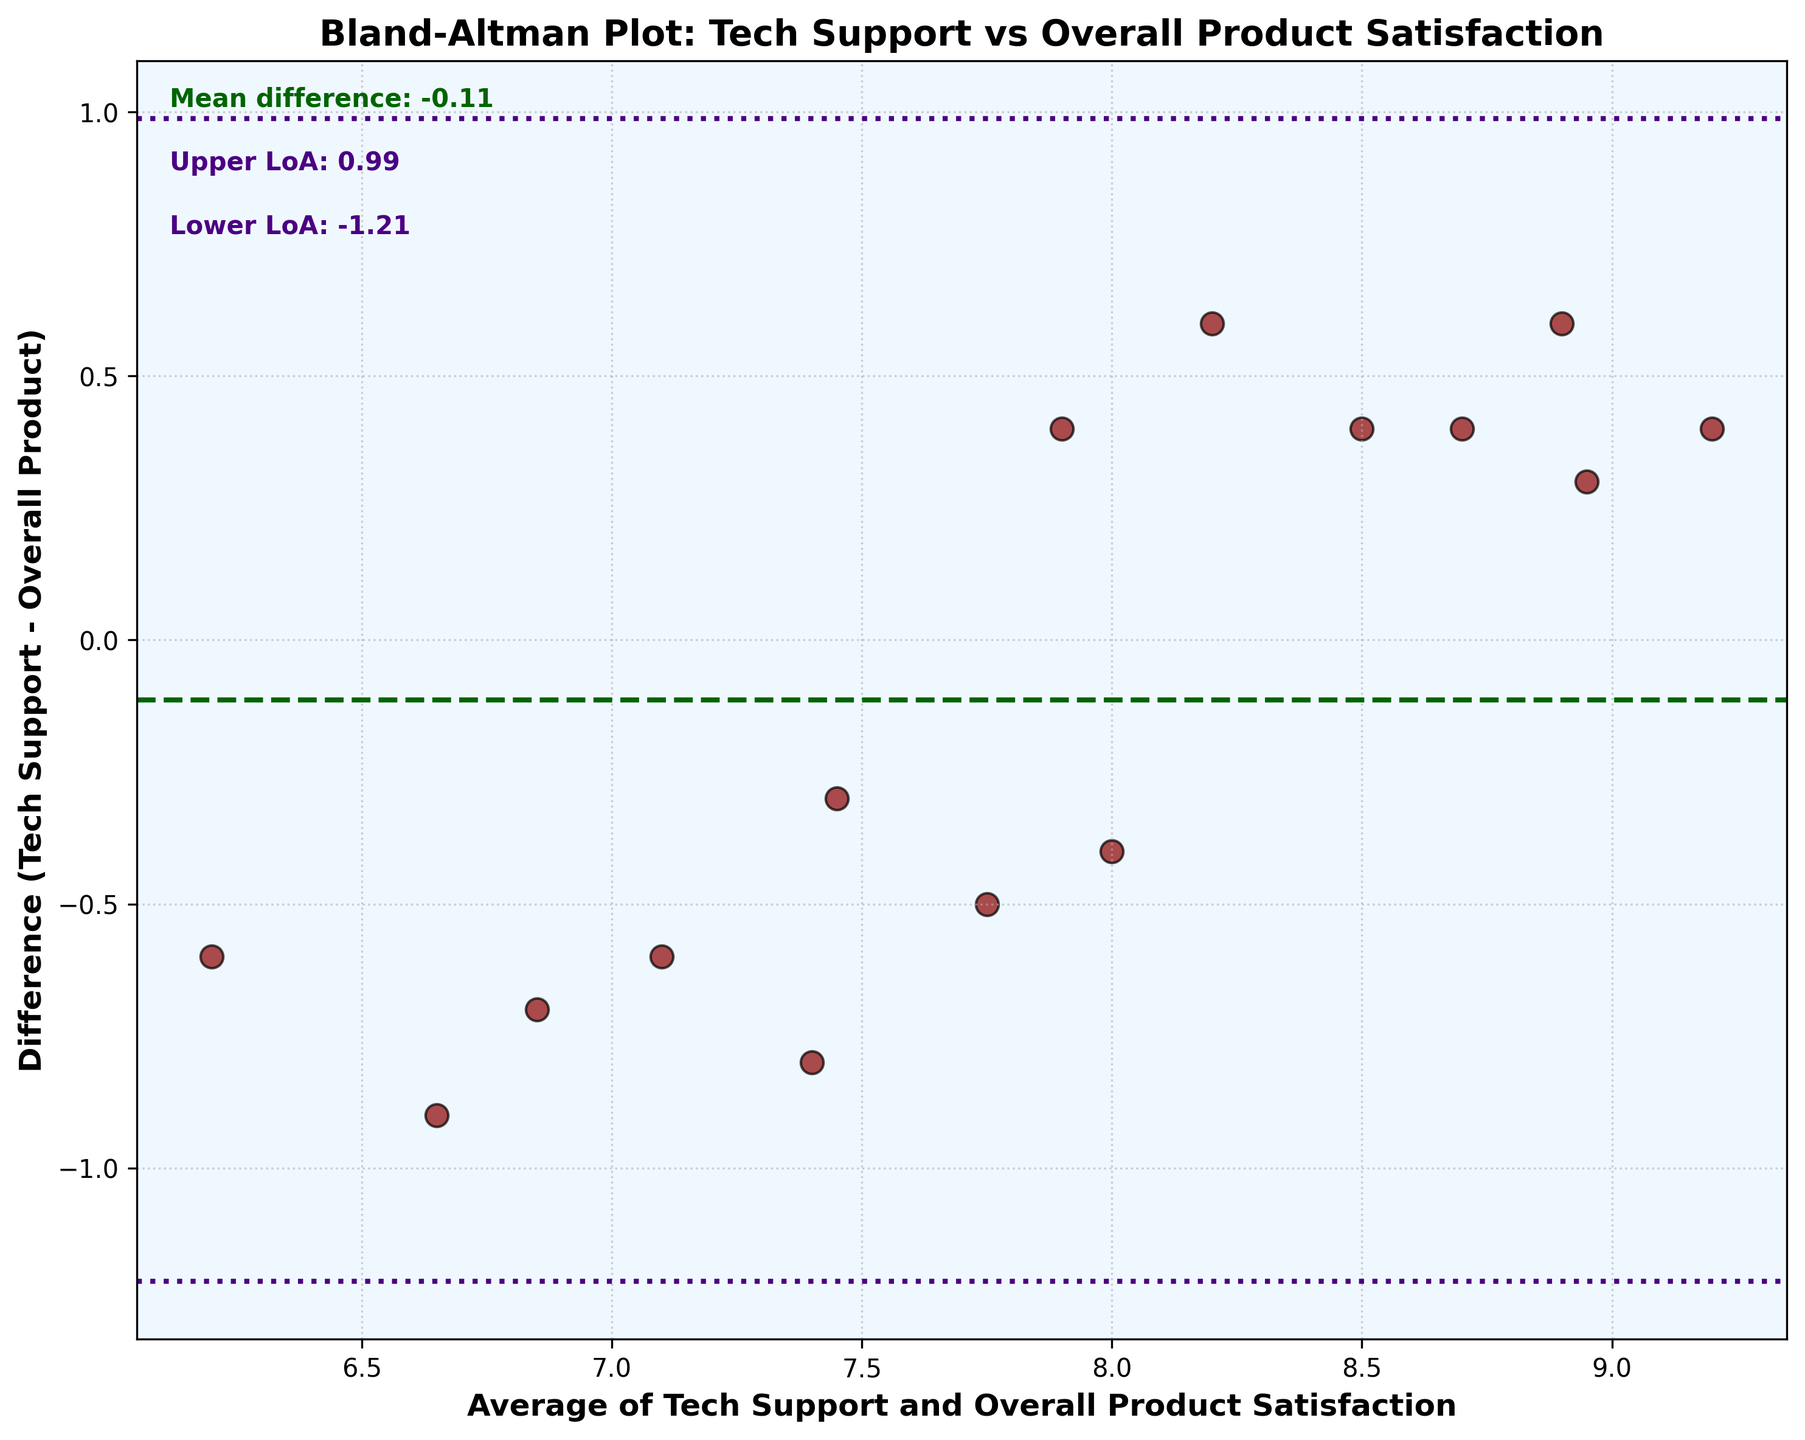What's the main title of the plot? The title is located at the top of the figure and provides an overview of what the plot represents. In this case, the main title is clearly written and easy to see.
Answer: Bland-Altman Plot: Tech Support vs Overall Product Satisfaction What is the mean difference between tech support satisfaction and overall product satisfaction? The mean difference is indicated by a dashed line on the plot, and there's text near the top left that specifies this value numerically.
Answer: 0.41 What do the upper and lower Limits of Agreement (LoA) represent on the plot? The Upper and Lower Limits of Agreement show the range within which most differences should lie. They are represented by dotted lines above and below the mean difference and are numerically specified near the mean difference text.
Answer: Upper: 1.65, Lower: -0.83 How many data points are there in the plot? Each data point is represented by a scatter point in the plot, and by counting them, we can determine the total number of data points. The data contains scores for 15 customers, resulting in 15 data points on the plot.
Answer: 15 What is the average value used on the x-axis? The x-axis represents the average of the tech support and overall product satisfaction scores for each customer. Averaging the values of x-axis coordinates can be visually verified but requires calculation from the dataset.
Answer: Varies per point (e.g., the point with coordinates averaging 7.4) Is the mean difference line above or below the x-axis? Observing the plot, the mean difference line (dashed line) is plotted slightly above the horizontal (x-axis).
Answer: Above Which color represents the scatter points of the data? The scatter points representing the customer satisfaction data are distinctly colored for visibility.
Answer: Dark Red Which customer has the highest tech support satisfaction score? By comparing the data values and identifying the maximum tech support satisfaction score in the figure, we see the highest point in the scatter plot or refer to the data. Customer 8 has the highest score for tech support.
Answer: Customer 8 (9.4) By how much does the upper Limit of Agreement (LoA) exceed the mean difference? The upper Limit of Agreement (LoA) value is 1.65, and the mean difference value is 0.41. We need to subtract the mean difference from the upper LoA.
Answer: 1.65 - 0.41 = 1.24 What does a positive mean difference indicate in the context of this plot? A positive mean difference indicates that, on average, the tech support satisfaction scores are higher than the overall product satisfaction scores. This can be inferred from the context that tech support satisfaction is generally rated higher.
Answer: Tech support satisfaction tends to be higher 